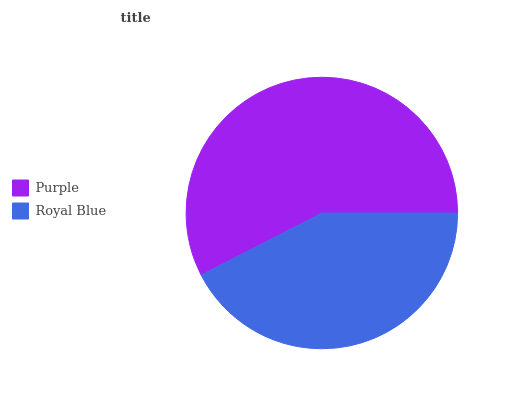Is Royal Blue the minimum?
Answer yes or no. Yes. Is Purple the maximum?
Answer yes or no. Yes. Is Royal Blue the maximum?
Answer yes or no. No. Is Purple greater than Royal Blue?
Answer yes or no. Yes. Is Royal Blue less than Purple?
Answer yes or no. Yes. Is Royal Blue greater than Purple?
Answer yes or no. No. Is Purple less than Royal Blue?
Answer yes or no. No. Is Purple the high median?
Answer yes or no. Yes. Is Royal Blue the low median?
Answer yes or no. Yes. Is Royal Blue the high median?
Answer yes or no. No. Is Purple the low median?
Answer yes or no. No. 